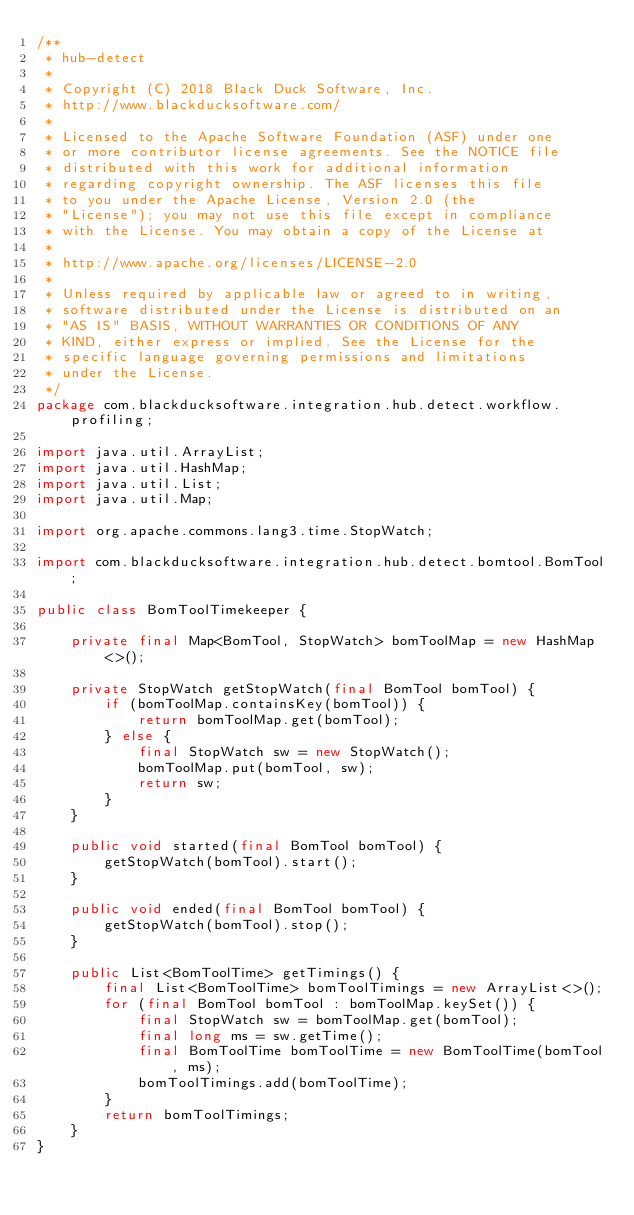<code> <loc_0><loc_0><loc_500><loc_500><_Java_>/**
 * hub-detect
 *
 * Copyright (C) 2018 Black Duck Software, Inc.
 * http://www.blackducksoftware.com/
 *
 * Licensed to the Apache Software Foundation (ASF) under one
 * or more contributor license agreements. See the NOTICE file
 * distributed with this work for additional information
 * regarding copyright ownership. The ASF licenses this file
 * to you under the Apache License, Version 2.0 (the
 * "License"); you may not use this file except in compliance
 * with the License. You may obtain a copy of the License at
 *
 * http://www.apache.org/licenses/LICENSE-2.0
 *
 * Unless required by applicable law or agreed to in writing,
 * software distributed under the License is distributed on an
 * "AS IS" BASIS, WITHOUT WARRANTIES OR CONDITIONS OF ANY
 * KIND, either express or implied. See the License for the
 * specific language governing permissions and limitations
 * under the License.
 */
package com.blackducksoftware.integration.hub.detect.workflow.profiling;

import java.util.ArrayList;
import java.util.HashMap;
import java.util.List;
import java.util.Map;

import org.apache.commons.lang3.time.StopWatch;

import com.blackducksoftware.integration.hub.detect.bomtool.BomTool;

public class BomToolTimekeeper {

    private final Map<BomTool, StopWatch> bomToolMap = new HashMap<>();

    private StopWatch getStopWatch(final BomTool bomTool) {
        if (bomToolMap.containsKey(bomTool)) {
            return bomToolMap.get(bomTool);
        } else {
            final StopWatch sw = new StopWatch();
            bomToolMap.put(bomTool, sw);
            return sw;
        }
    }

    public void started(final BomTool bomTool) {
        getStopWatch(bomTool).start();
    }

    public void ended(final BomTool bomTool) {
        getStopWatch(bomTool).stop();
    }

    public List<BomToolTime> getTimings() {
        final List<BomToolTime> bomToolTimings = new ArrayList<>();
        for (final BomTool bomTool : bomToolMap.keySet()) {
            final StopWatch sw = bomToolMap.get(bomTool);
            final long ms = sw.getTime();
            final BomToolTime bomToolTime = new BomToolTime(bomTool, ms);
            bomToolTimings.add(bomToolTime);
        }
        return bomToolTimings;
    }
}
</code> 